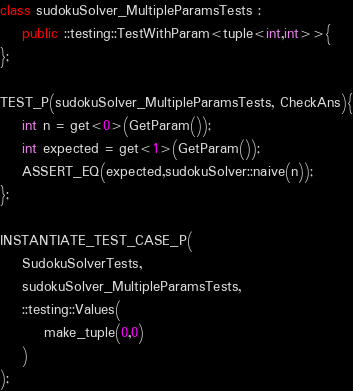<code> <loc_0><loc_0><loc_500><loc_500><_C++_>class sudokuSolver_MultipleParamsTests : 
    public ::testing::TestWithParam<tuple<int,int>>{
};

TEST_P(sudokuSolver_MultipleParamsTests, CheckAns){
    int n = get<0>(GetParam());
    int expected = get<1>(GetParam());
    ASSERT_EQ(expected,sudokuSolver::naive(n));
};

INSTANTIATE_TEST_CASE_P(
    SudokuSolverTests,
    sudokuSolver_MultipleParamsTests,
    ::testing::Values(
        make_tuple(0,0)
    )
);
</code> 